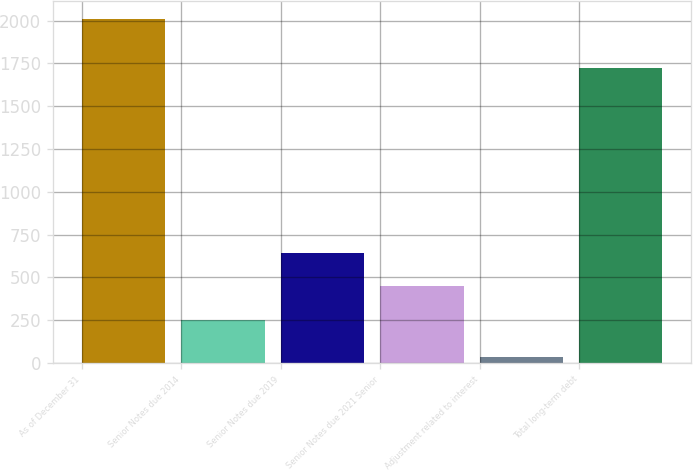Convert chart. <chart><loc_0><loc_0><loc_500><loc_500><bar_chart><fcel>As of December 31<fcel>Senior Notes due 2014<fcel>Senior Notes due 2019<fcel>Senior Notes due 2021 Senior<fcel>Adjustment related to interest<fcel>Total long-term debt<nl><fcel>2012<fcel>250<fcel>645.62<fcel>447.81<fcel>33.9<fcel>1720.8<nl></chart> 